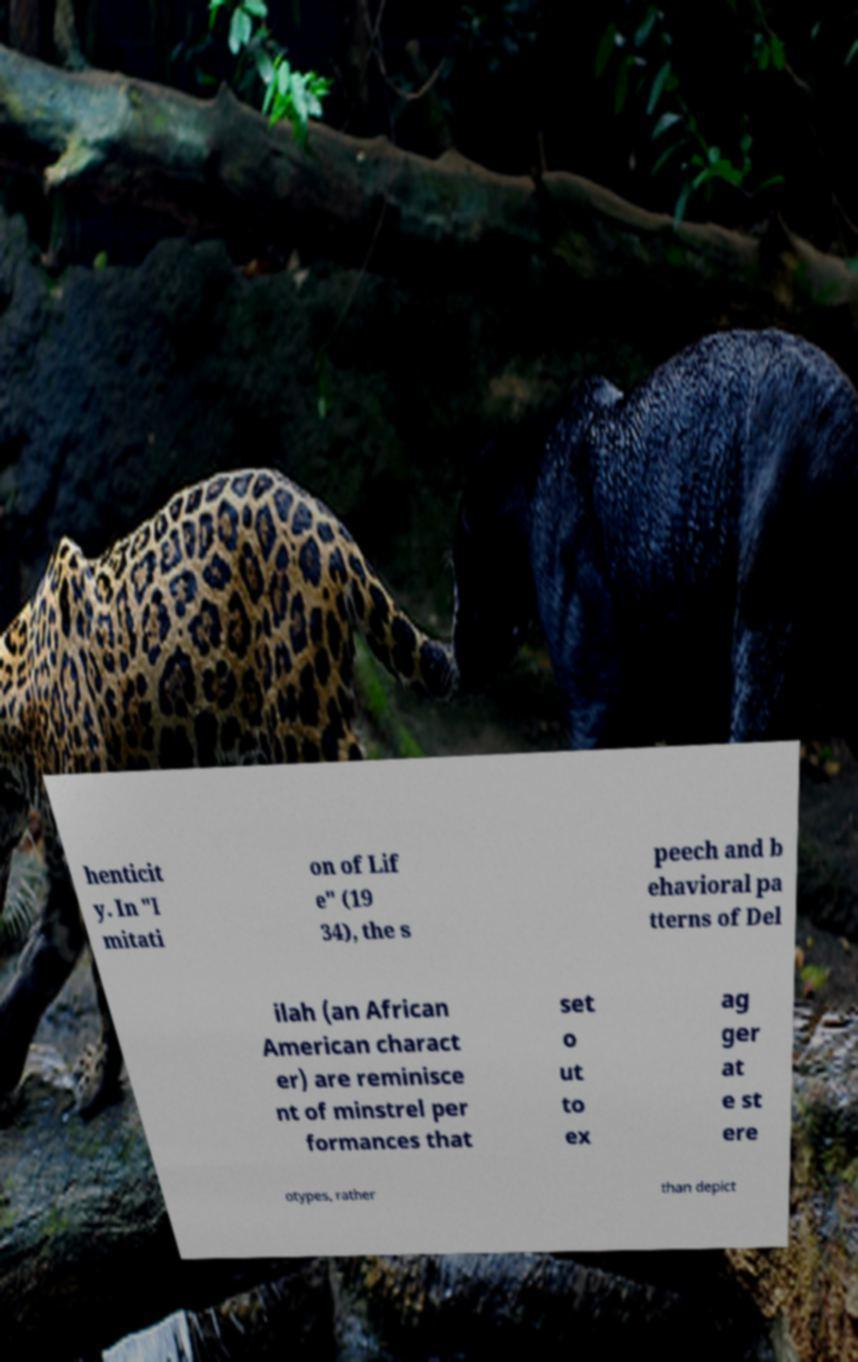Can you read and provide the text displayed in the image?This photo seems to have some interesting text. Can you extract and type it out for me? henticit y. In "I mitati on of Lif e" (19 34), the s peech and b ehavioral pa tterns of Del ilah (an African American charact er) are reminisce nt of minstrel per formances that set o ut to ex ag ger at e st ere otypes, rather than depict 